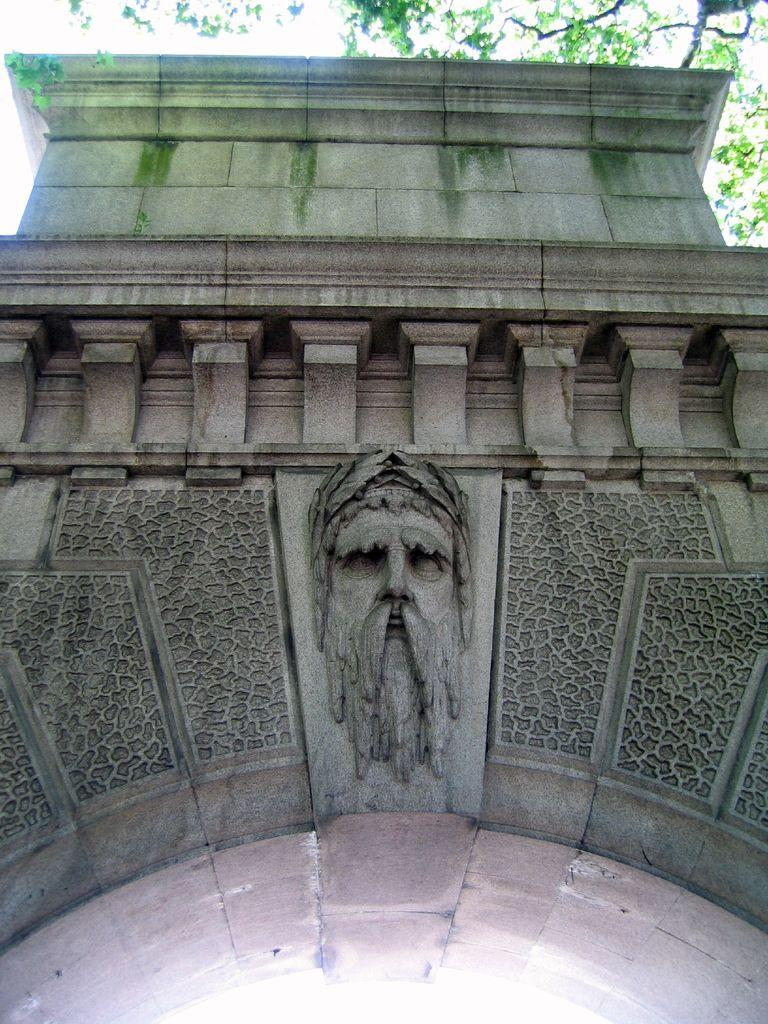What is the main subject in the center of the image? There is a sculpture in the center of the image. What can be seen in the background of the image? There is a wall in the background of the image. What type of natural elements are visible at the top of the image? Trees are visible at the top of the image. How does the sculpture breathe in the image? The sculpture is an inanimate object and does not breathe in the image. 